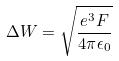<formula> <loc_0><loc_0><loc_500><loc_500>\Delta W = \sqrt { \frac { e ^ { 3 } F } { 4 \pi \epsilon _ { 0 } } }</formula> 